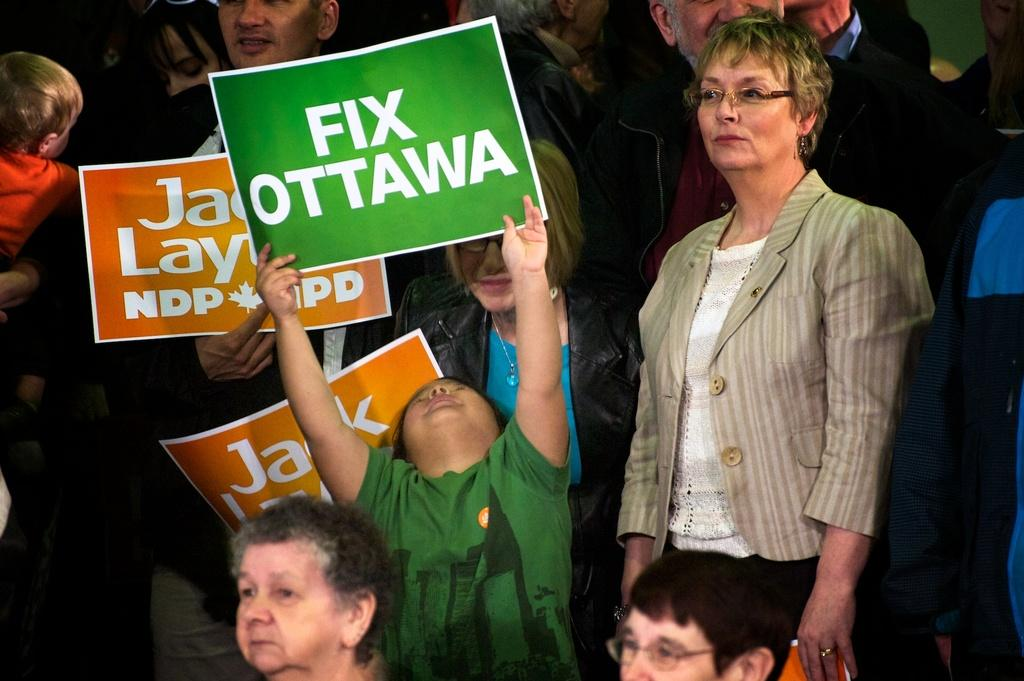What types of individuals are present in the image? There are kids and other people in the image. What are the people in the image doing? The people are standing and holding placards. Where is the hall located in the image? There is no hall present in the image. What type of cap is the child wearing in the image? There is no cap visible on any of the children in the image. 